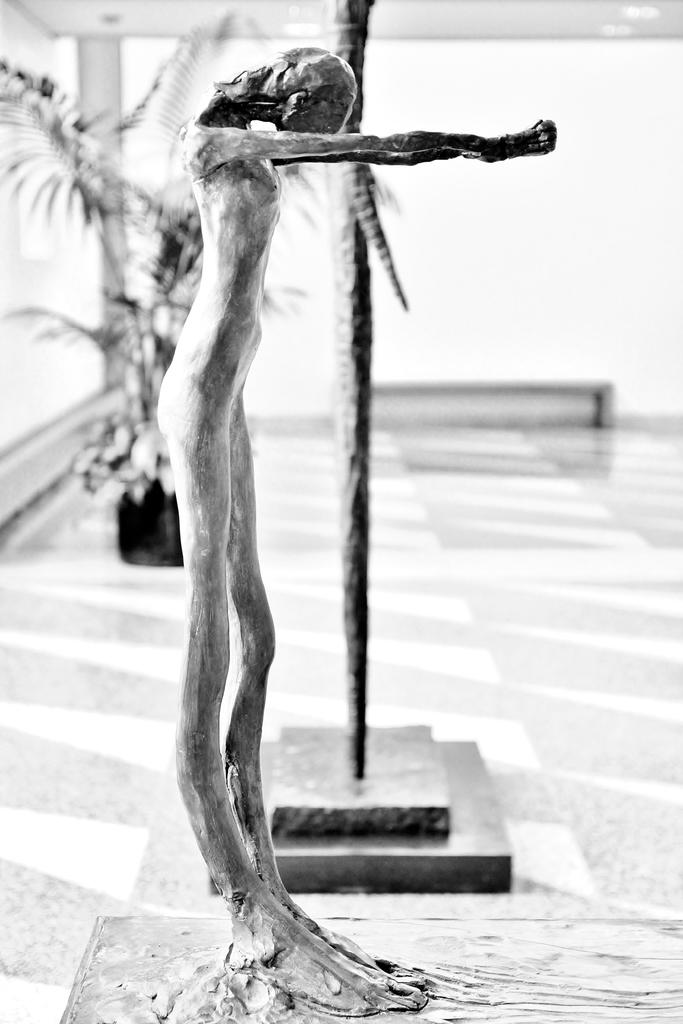What is the main subject in the image? There is a statue in the image. Can you describe the background of the image? The background of the image is blurry. What else can be seen in the background of the image? There is a plant visible in the background of the image. What type of jam is being spread on the bread in the image? There is no jam or bread present in the image; it features a statue and a blurry background with a plant. 